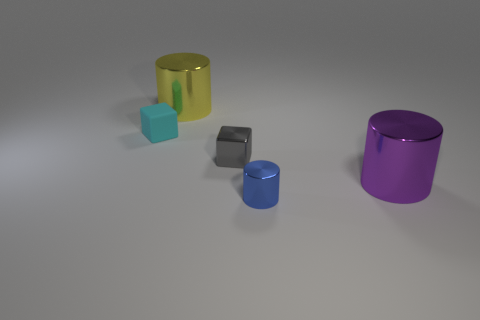There is another shiny thing that is the same size as the gray shiny thing; what shape is it?
Offer a terse response. Cylinder. There is a big cylinder that is to the right of the blue shiny cylinder; what number of big shiny cylinders are to the left of it?
Make the answer very short. 1. How many other objects are there of the same material as the tiny cyan object?
Provide a short and direct response. 0. The large object that is right of the small shiny block that is on the left side of the big purple shiny cylinder is what shape?
Provide a short and direct response. Cylinder. How big is the cylinder to the left of the blue metallic thing?
Provide a short and direct response. Large. Do the tiny gray cube and the small cyan thing have the same material?
Keep it short and to the point. No. The gray thing that is the same material as the large yellow thing is what shape?
Provide a succinct answer. Cube. Is there any other thing that has the same color as the tiny shiny block?
Your answer should be compact. No. What color is the large cylinder in front of the yellow shiny cylinder?
Your answer should be very brief. Purple. What is the material of the yellow object that is the same shape as the blue shiny thing?
Your answer should be compact. Metal. 